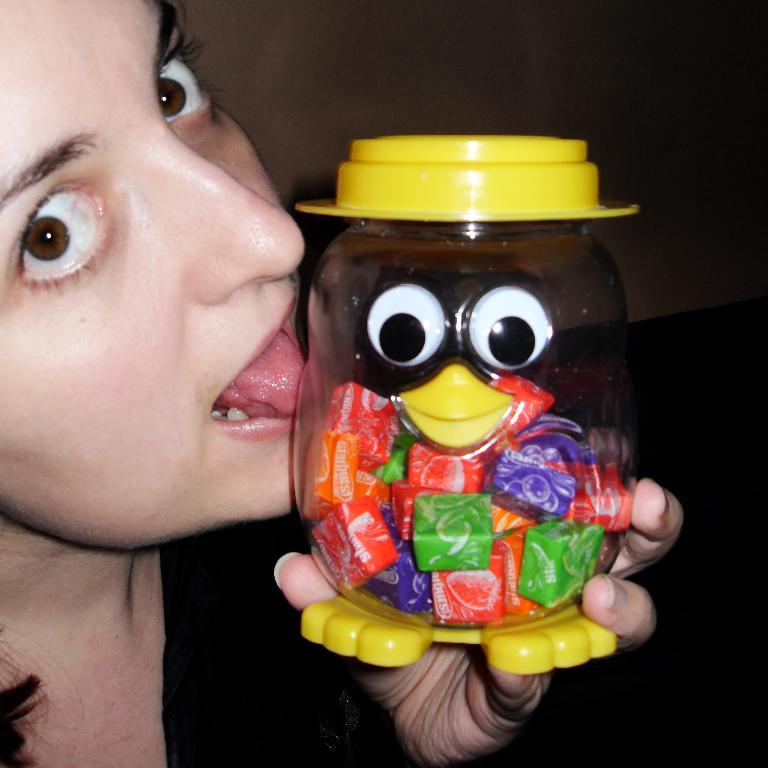Who is the main subject in the image? There is a girl in the image. What is the girl holding in the image? The girl is holding a bottle. What is inside the bottle that the girl is holding? The bottle contains candies. What type of control system is the girl using to manage the mailbox in the image? There is no mailbox present in the image, and the girl is not using any control system. 